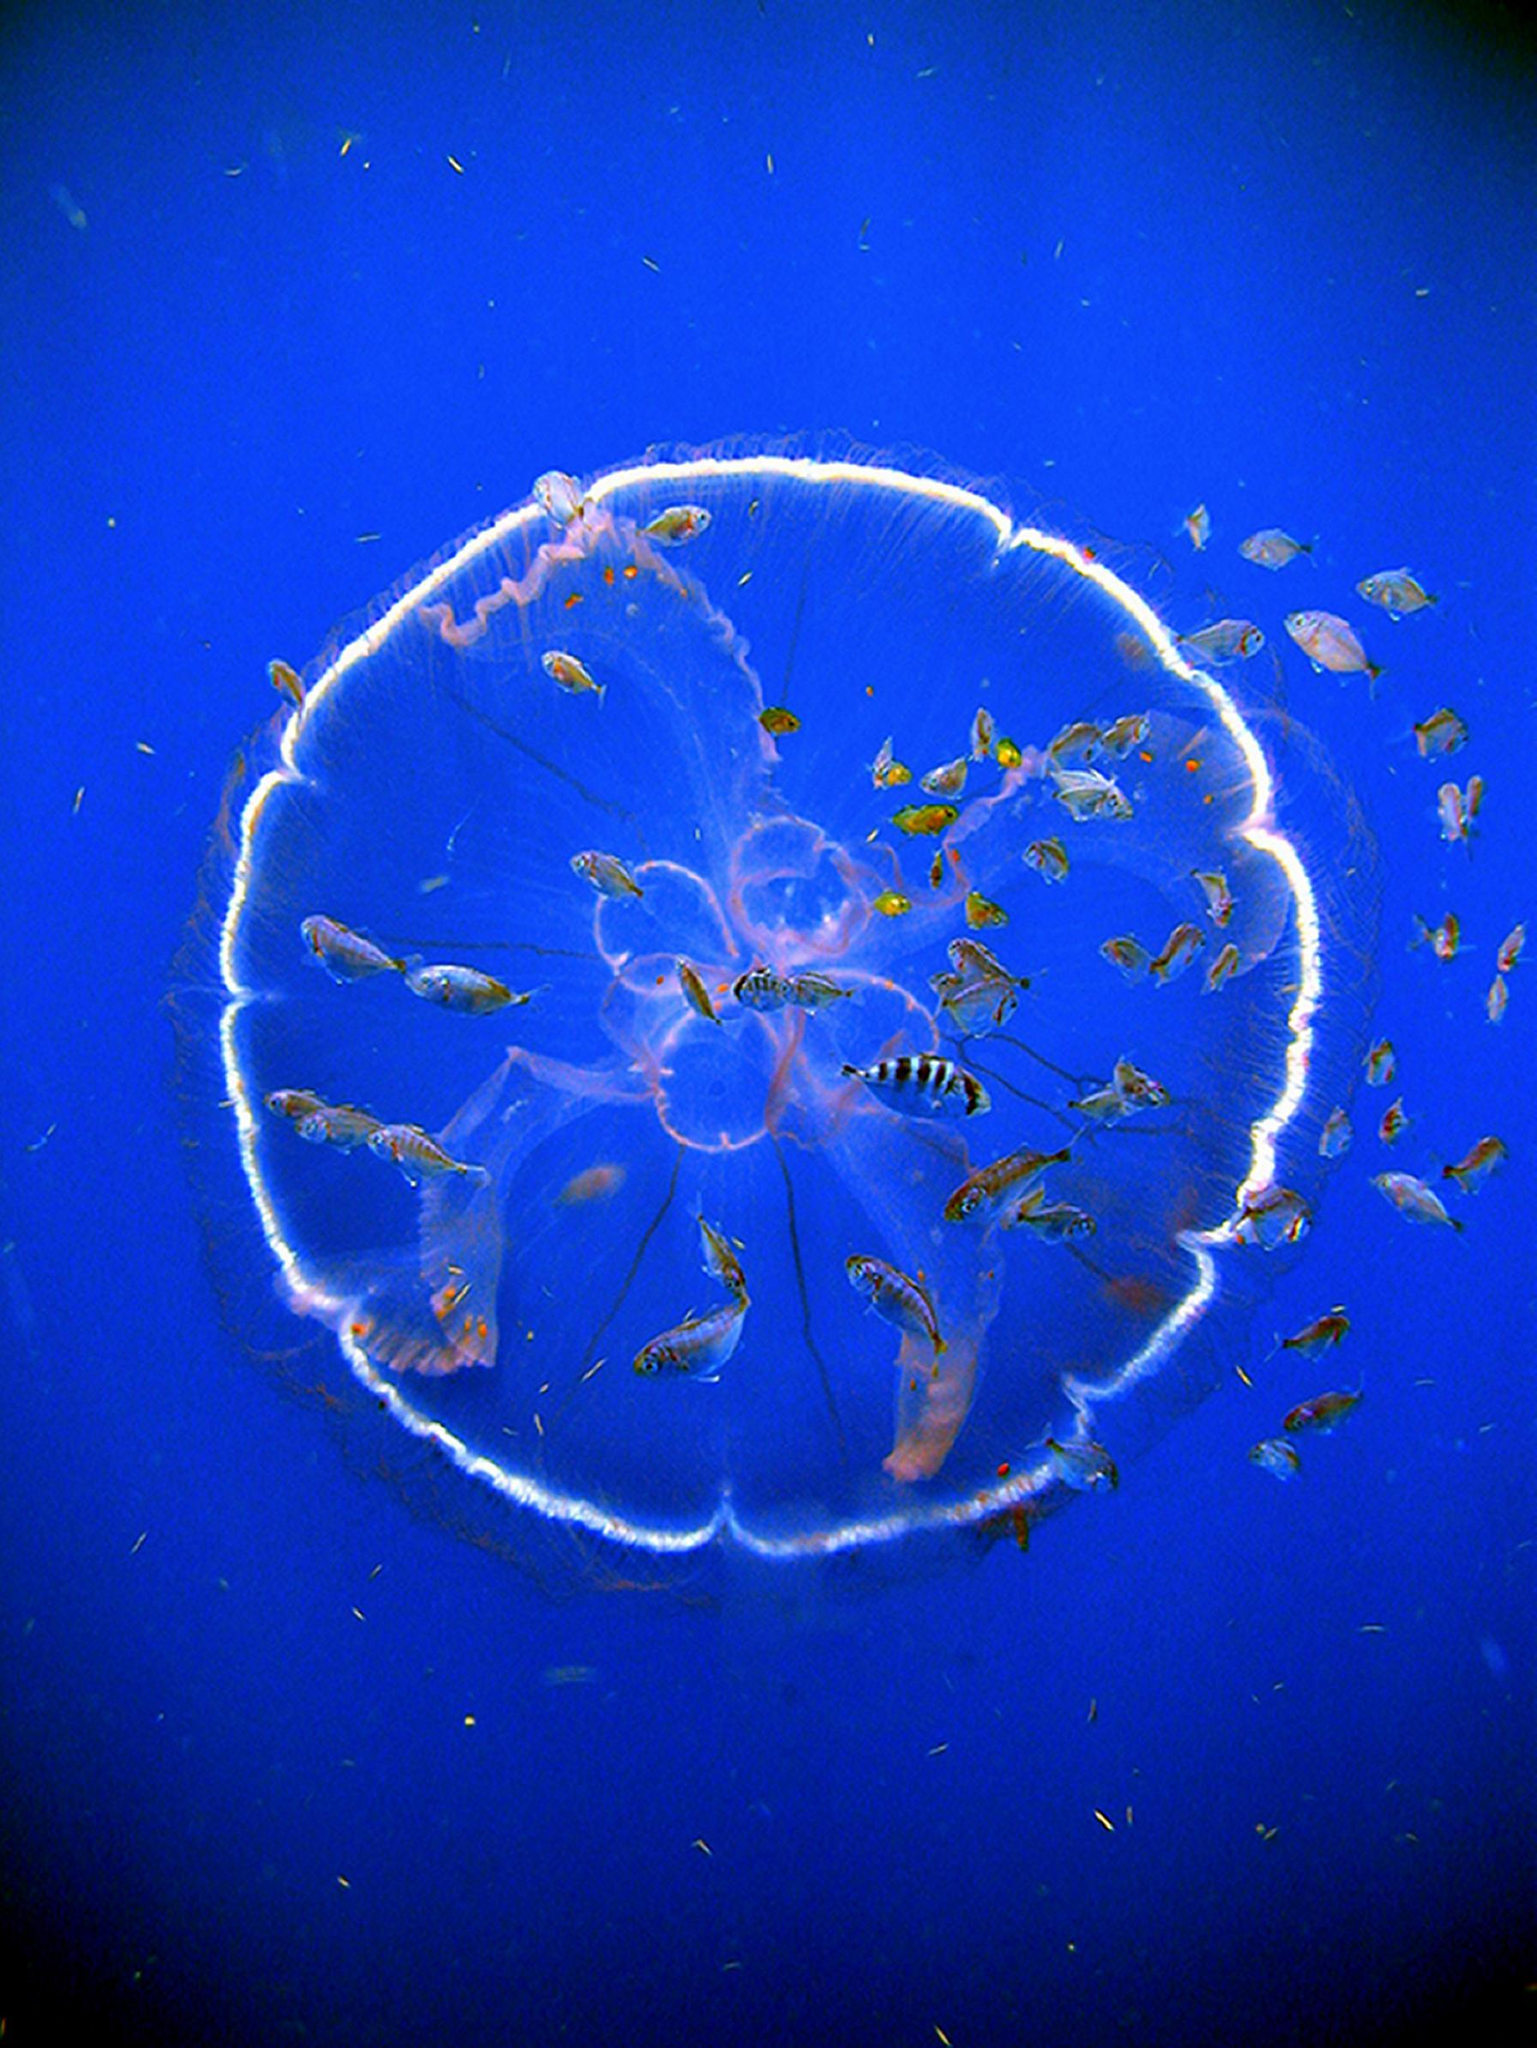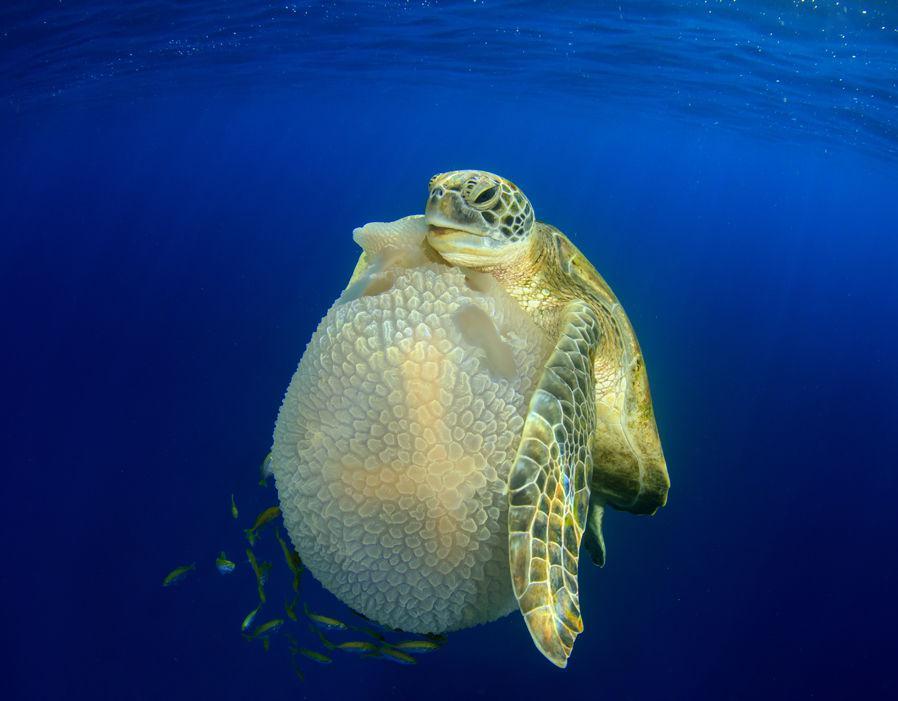The first image is the image on the left, the second image is the image on the right. Assess this claim about the two images: "The left image contains one round jellyfish with glowing white color, and the right image features a sea turtle next to a round shape.". Correct or not? Answer yes or no. Yes. 